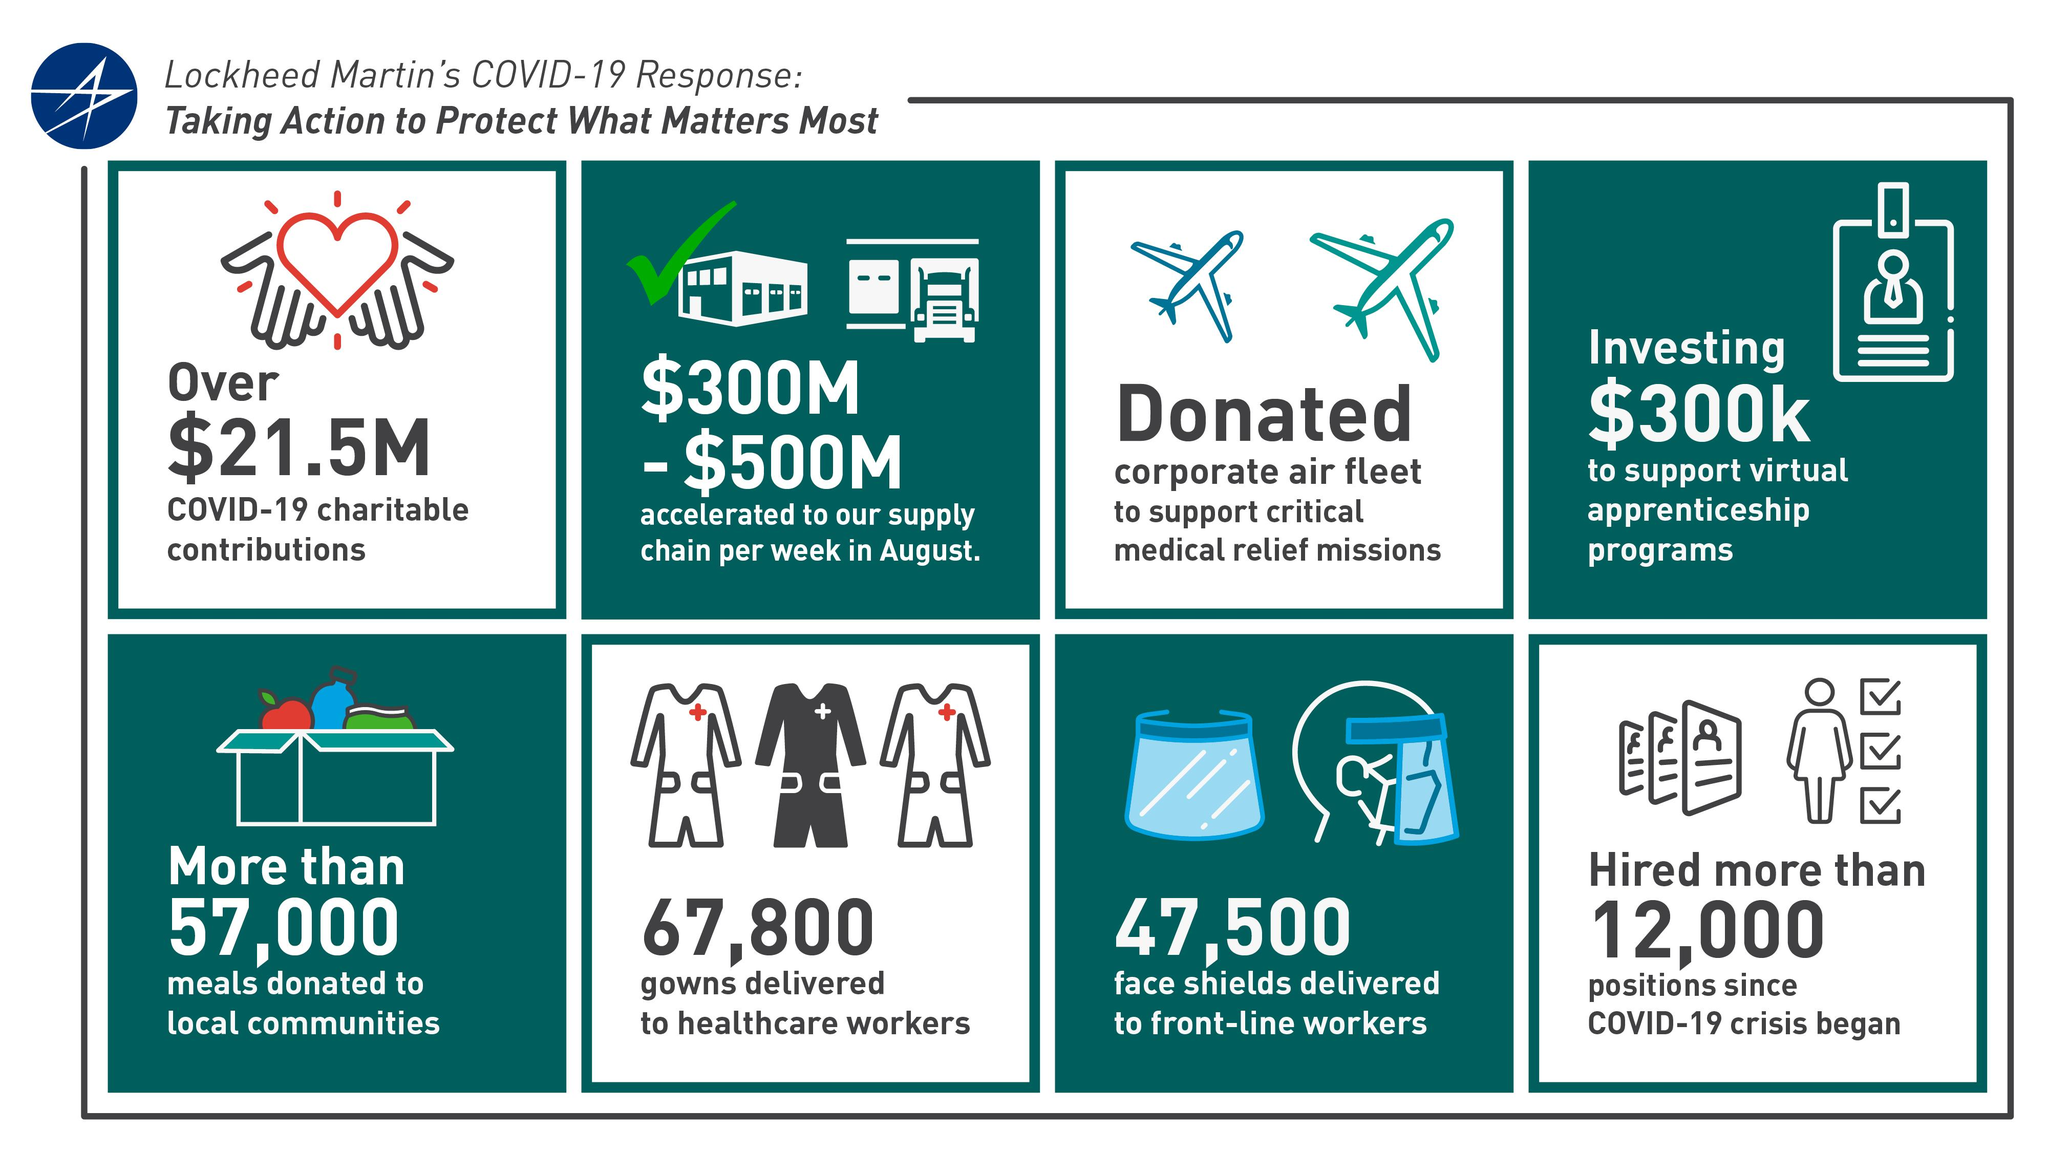Give some essential details in this illustration. The amount transferred to the supply chain to address the Covid-19 crisis was estimated to be between $300 million and $500 million. Approximately $300,000 was provided to support virtual apprenticeship programs. A total of 67,800 dresses were shipped to medical staff. Last year, over 57,000 food packets were delivered to regional communities. In an effort to provide urgent medical care, our corporate air fleet has been initiated to ensure prompt and efficient transportation of patients to the nearest medical facilities. 